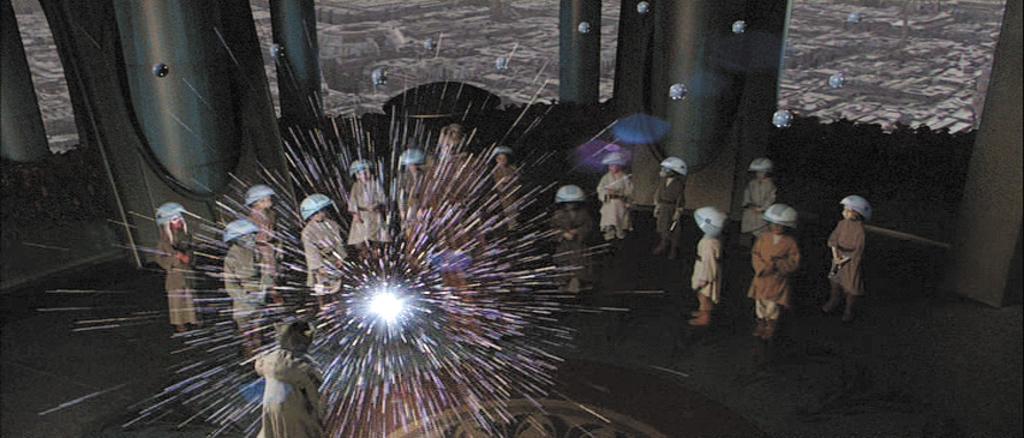Describe this image in one or two sentences. In this image I can see group of people standing wearing brown color dress. Background I can see a wall in brown color. 